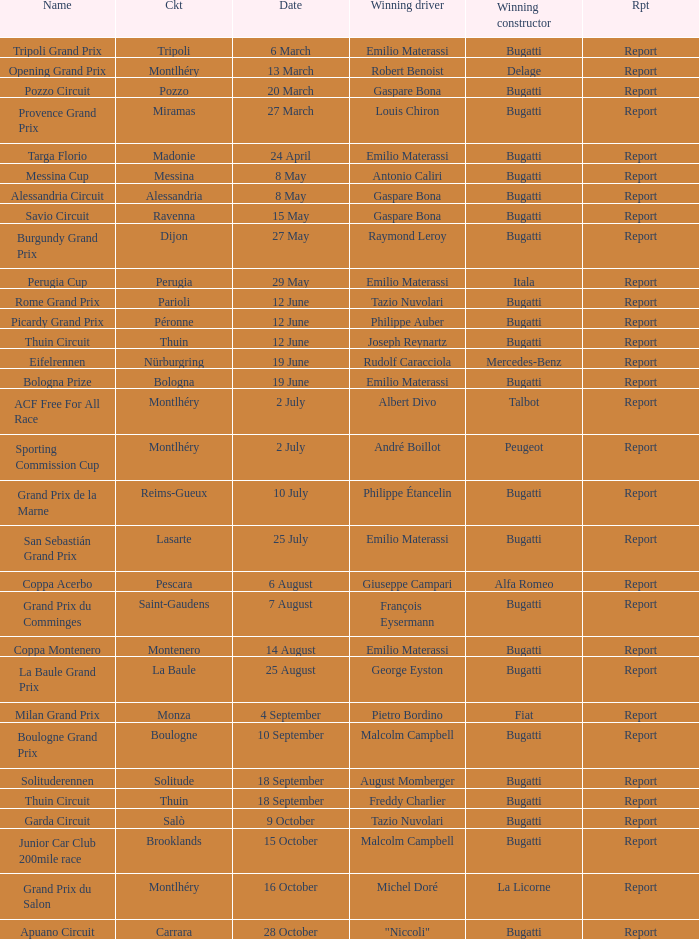When did Gaspare Bona win the Pozzo Circuit? 20 March. 